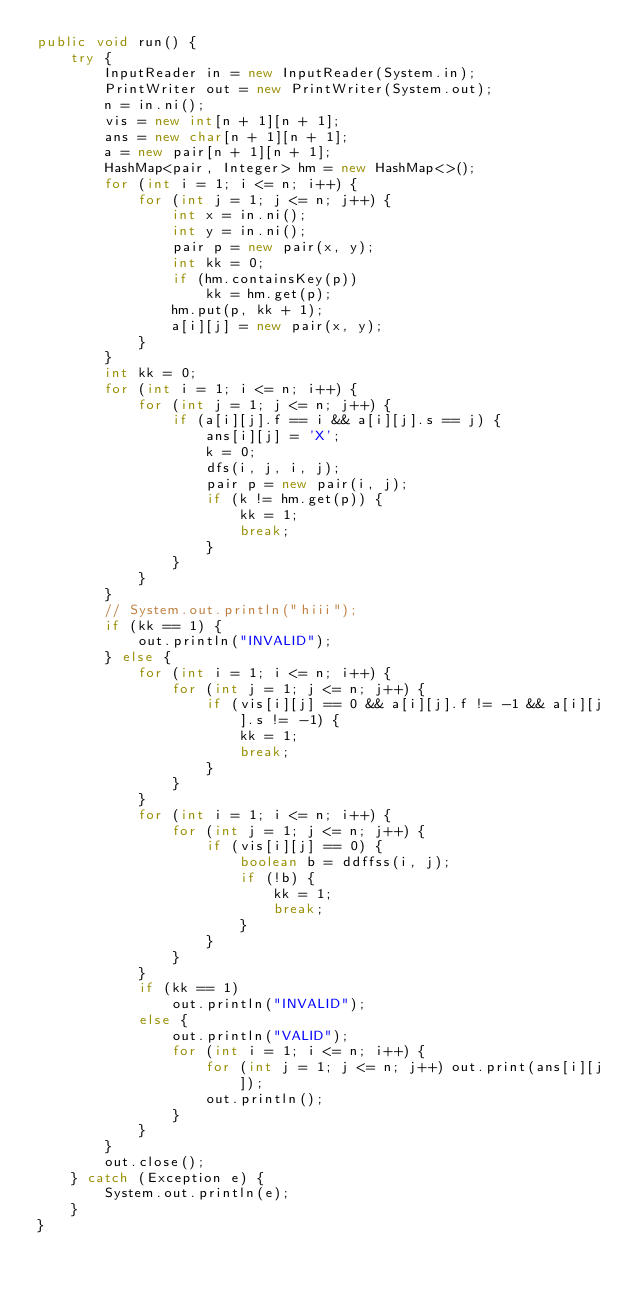<code> <loc_0><loc_0><loc_500><loc_500><_Java_>public void run() {
    try {
        InputReader in = new InputReader(System.in);
        PrintWriter out = new PrintWriter(System.out);
        n = in.ni();
        vis = new int[n + 1][n + 1];
        ans = new char[n + 1][n + 1];
        a = new pair[n + 1][n + 1];
        HashMap<pair, Integer> hm = new HashMap<>();
        for (int i = 1; i <= n; i++) {
            for (int j = 1; j <= n; j++) {
                int x = in.ni();
                int y = in.ni();
                pair p = new pair(x, y);
                int kk = 0;
                if (hm.containsKey(p))
                    kk = hm.get(p);
                hm.put(p, kk + 1);
                a[i][j] = new pair(x, y);
            }
        }
        int kk = 0;
        for (int i = 1; i <= n; i++) {
            for (int j = 1; j <= n; j++) {
                if (a[i][j].f == i && a[i][j].s == j) {
                    ans[i][j] = 'X';
                    k = 0;
                    dfs(i, j, i, j);
                    pair p = new pair(i, j);
                    if (k != hm.get(p)) {
                        kk = 1;
                        break;
                    }
                }
            }
        }
        // System.out.println("hiii");
        if (kk == 1) {
            out.println("INVALID");
        } else {
            for (int i = 1; i <= n; i++) {
                for (int j = 1; j <= n; j++) {
                    if (vis[i][j] == 0 && a[i][j].f != -1 && a[i][j].s != -1) {
                        kk = 1;
                        break;
                    }
                }
            }
            for (int i = 1; i <= n; i++) {
                for (int j = 1; j <= n; j++) {
                    if (vis[i][j] == 0) {
                        boolean b = ddffss(i, j);
                        if (!b) {
                            kk = 1;
                            break;
                        }
                    }
                }
            }
            if (kk == 1)
                out.println("INVALID");
            else {
                out.println("VALID");
                for (int i = 1; i <= n; i++) {
                    for (int j = 1; j <= n; j++) out.print(ans[i][j]);
                    out.println();
                }
            }
        }
        out.close();
    } catch (Exception e) {
        System.out.println(e);
    }
}</code> 